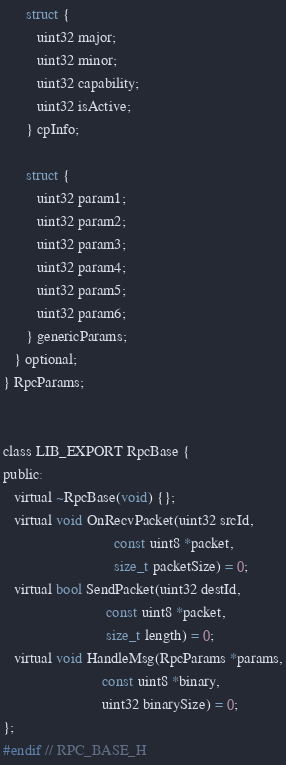<code> <loc_0><loc_0><loc_500><loc_500><_C_>
      struct {
         uint32 major;
         uint32 minor;
         uint32 capability;
         uint32 isActive;
      } cpInfo;

      struct {
         uint32 param1;
         uint32 param2;
         uint32 param3;
         uint32 param4;
         uint32 param5;
         uint32 param6;
      } genericParams;
   } optional;
} RpcParams;


class LIB_EXPORT RpcBase {
public:
   virtual ~RpcBase(void) {};
   virtual void OnRecvPacket(uint32 srcId,
                             const uint8 *packet,
                             size_t packetSize) = 0;
   virtual bool SendPacket(uint32 destId,
                           const uint8 *packet,
                           size_t length) = 0;
   virtual void HandleMsg(RpcParams *params,
                          const uint8 *binary,
                          uint32 binarySize) = 0;
};
#endif // RPC_BASE_H
</code> 